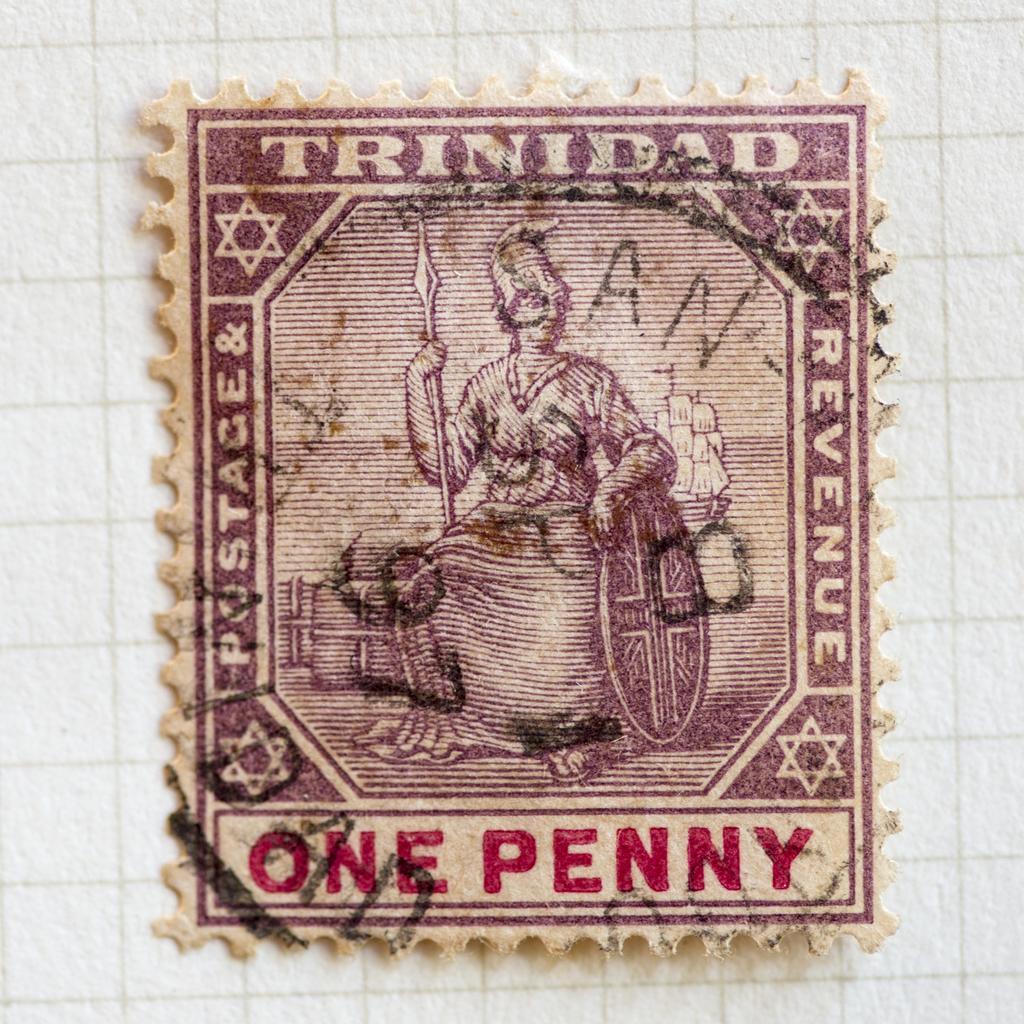How would you summarize this image in a sentence or two? Here in this picture we can see a stamp present on a place over there and in that stamp we can see a person with a shield and fighting sword present in hand over there. 